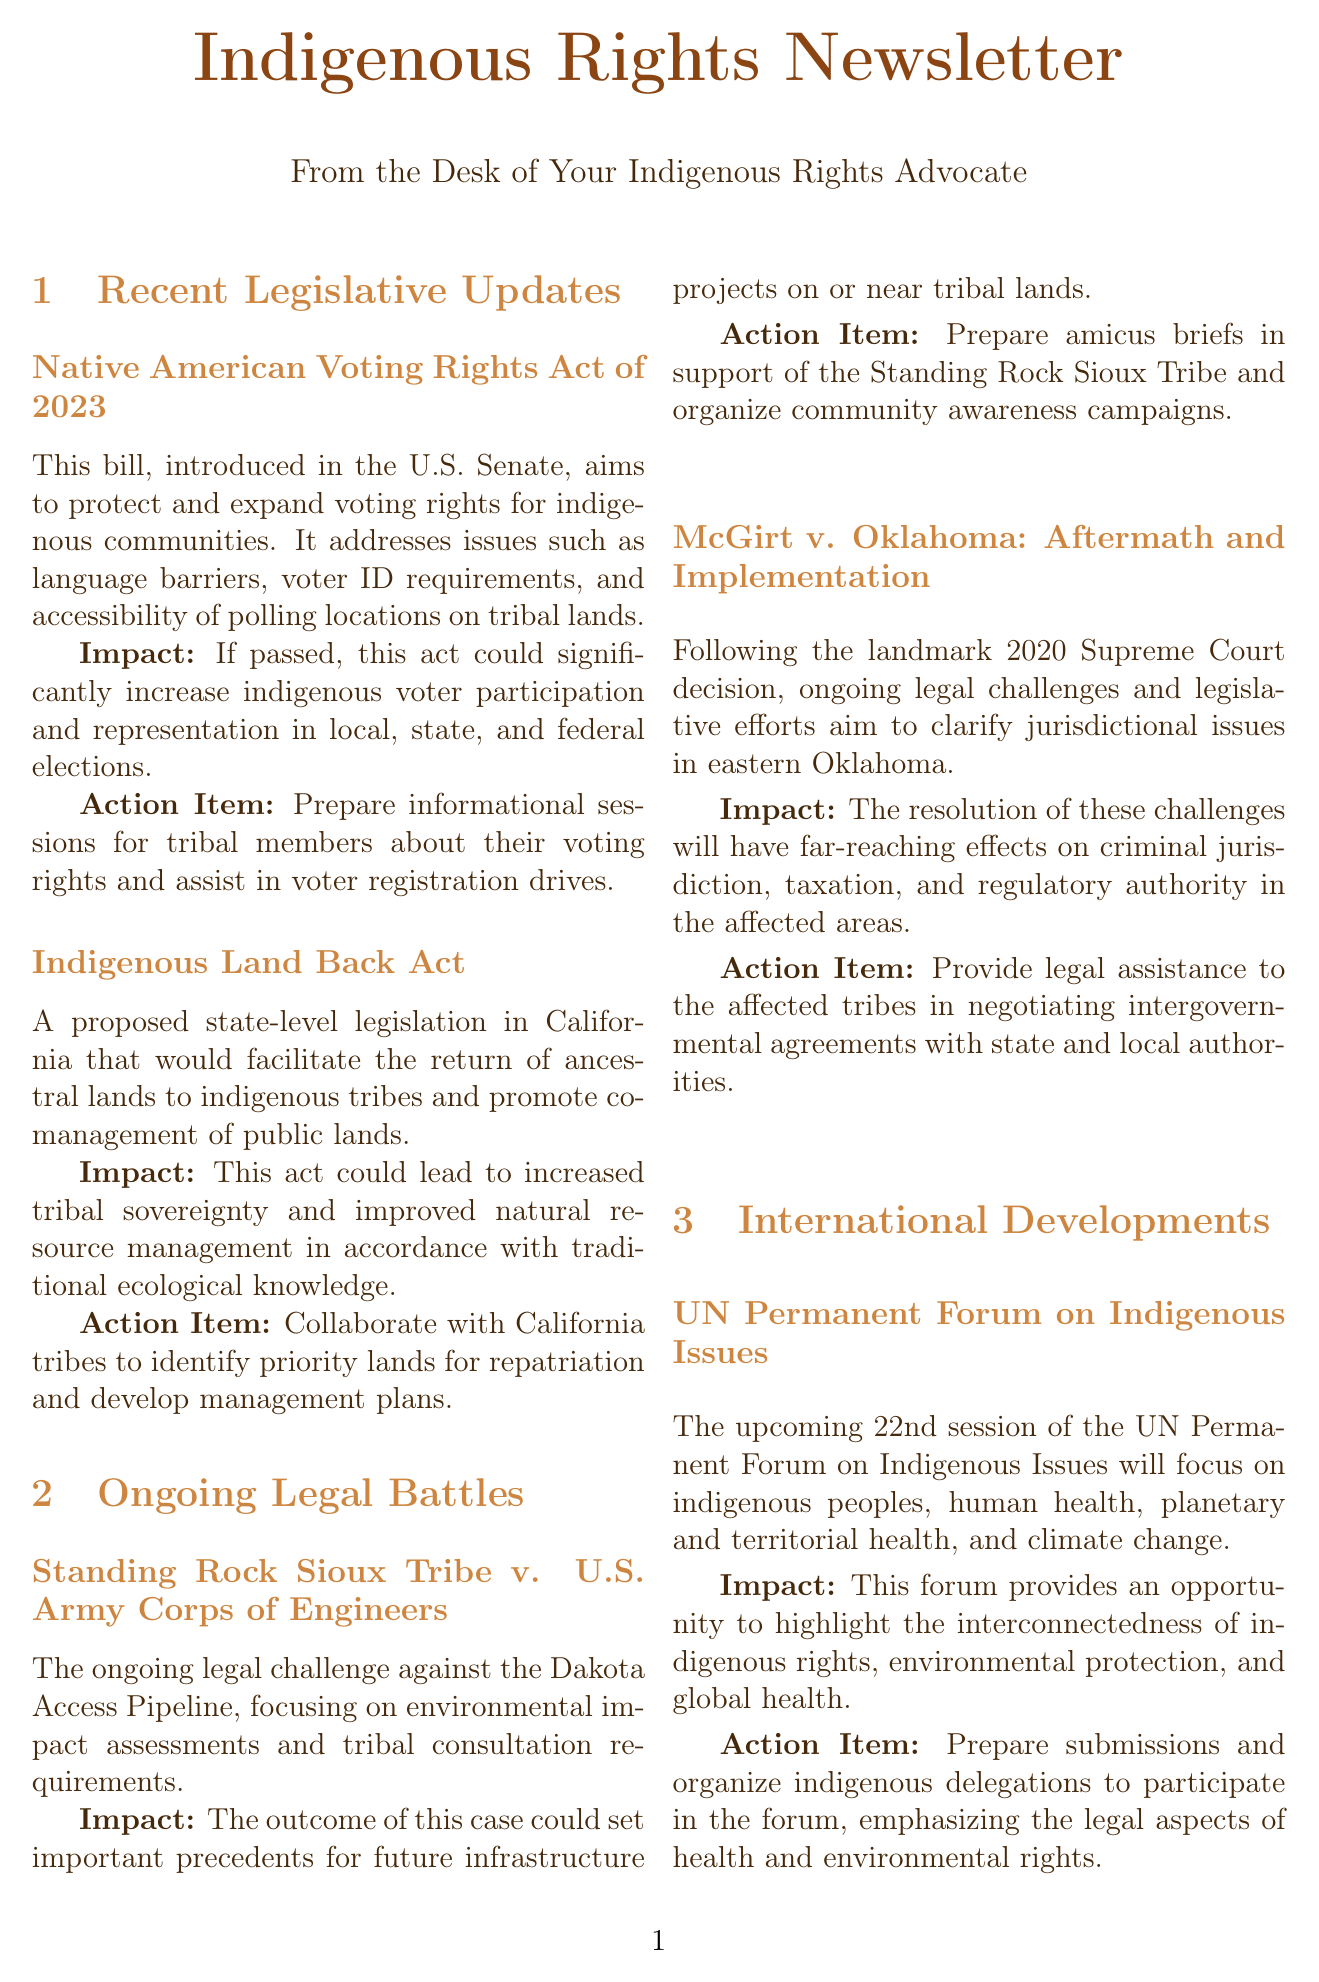what is the name of the bill that aims to protect and expand voting rights for indigenous communities? The document mentions the "Native American Voting Rights Act of 2023" as the bill focused on indigenous voting rights.
Answer: Native American Voting Rights Act of 2023 what is a proposed action item for the Indigenous Land Back Act? The document states that the action item is to "Collaborate with California tribes to identify priority lands for repatriation and develop management plans."
Answer: Collaborate with California tribes to identify priority lands for repatriation and develop management plans what ongoing legal case involves the Dakota Access Pipeline? The document specifies the case "Standing Rock Sioux Tribe v. U.S. Army Corps of Engineers" as related to the Dakota Access Pipeline.
Answer: Standing Rock Sioux Tribe v. U.S. Army Corps of Engineers how does the UN Permanent Forum on Indigenous Issues impact indigenous rights? The document notes that the forum highlights the interconnectedness of indigenous rights, environmental protection, and global health.
Answer: Interconnectedness of indigenous rights, environmental protection, and global health what initiative aims to provide legal education and resources to indigenous communities? According to the document, the initiative titled "Indigenous Legal Empowerment Program" is focused on legal education for indigenous communities.
Answer: Indigenous Legal Empowerment Program 